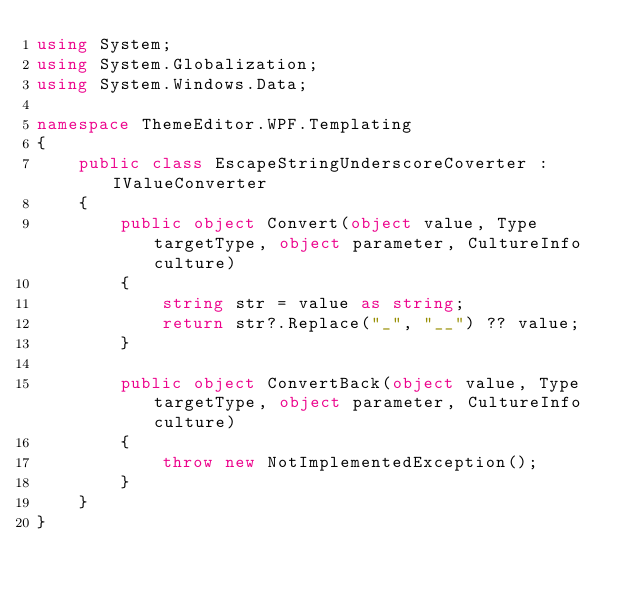<code> <loc_0><loc_0><loc_500><loc_500><_C#_>using System;
using System.Globalization;
using System.Windows.Data;

namespace ThemeEditor.WPF.Templating
{
    public class EscapeStringUnderscoreCoverter : IValueConverter
    {
        public object Convert(object value, Type targetType, object parameter, CultureInfo culture)
        {
            string str = value as string;
            return str?.Replace("_", "__") ?? value;
        }

        public object ConvertBack(object value, Type targetType, object parameter, CultureInfo culture)
        {
            throw new NotImplementedException();
        }
    }
}</code> 